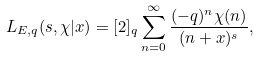<formula> <loc_0><loc_0><loc_500><loc_500>L _ { E , q } ( s , \chi | x ) = [ 2 ] _ { q } \sum _ { n = 0 } ^ { \infty } \frac { ( - q ) ^ { n } \chi ( n ) } { ( n + x ) ^ { s } } ,</formula> 